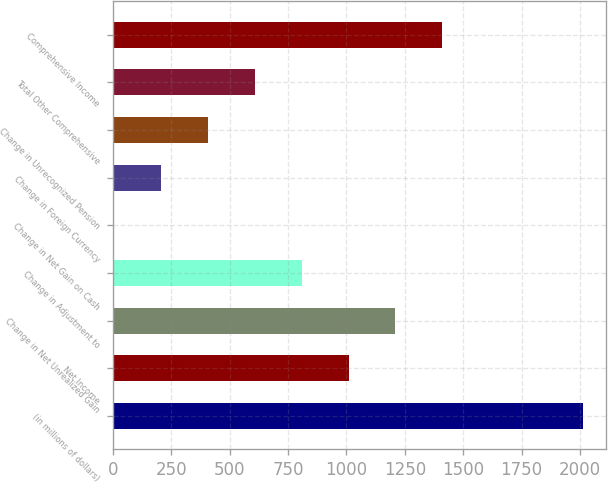Convert chart. <chart><loc_0><loc_0><loc_500><loc_500><bar_chart><fcel>(in millions of dollars)<fcel>Net Income<fcel>Change in Net Unrealized Gain<fcel>Change in Adjustment to<fcel>Change in Net Gain on Cash<fcel>Change in Foreign Currency<fcel>Change in Unrecognized Pension<fcel>Total Other Comprehensive<fcel>Comprehensive Income<nl><fcel>2012<fcel>1009.55<fcel>1210.04<fcel>809.06<fcel>7.1<fcel>207.59<fcel>408.08<fcel>608.57<fcel>1410.53<nl></chart> 